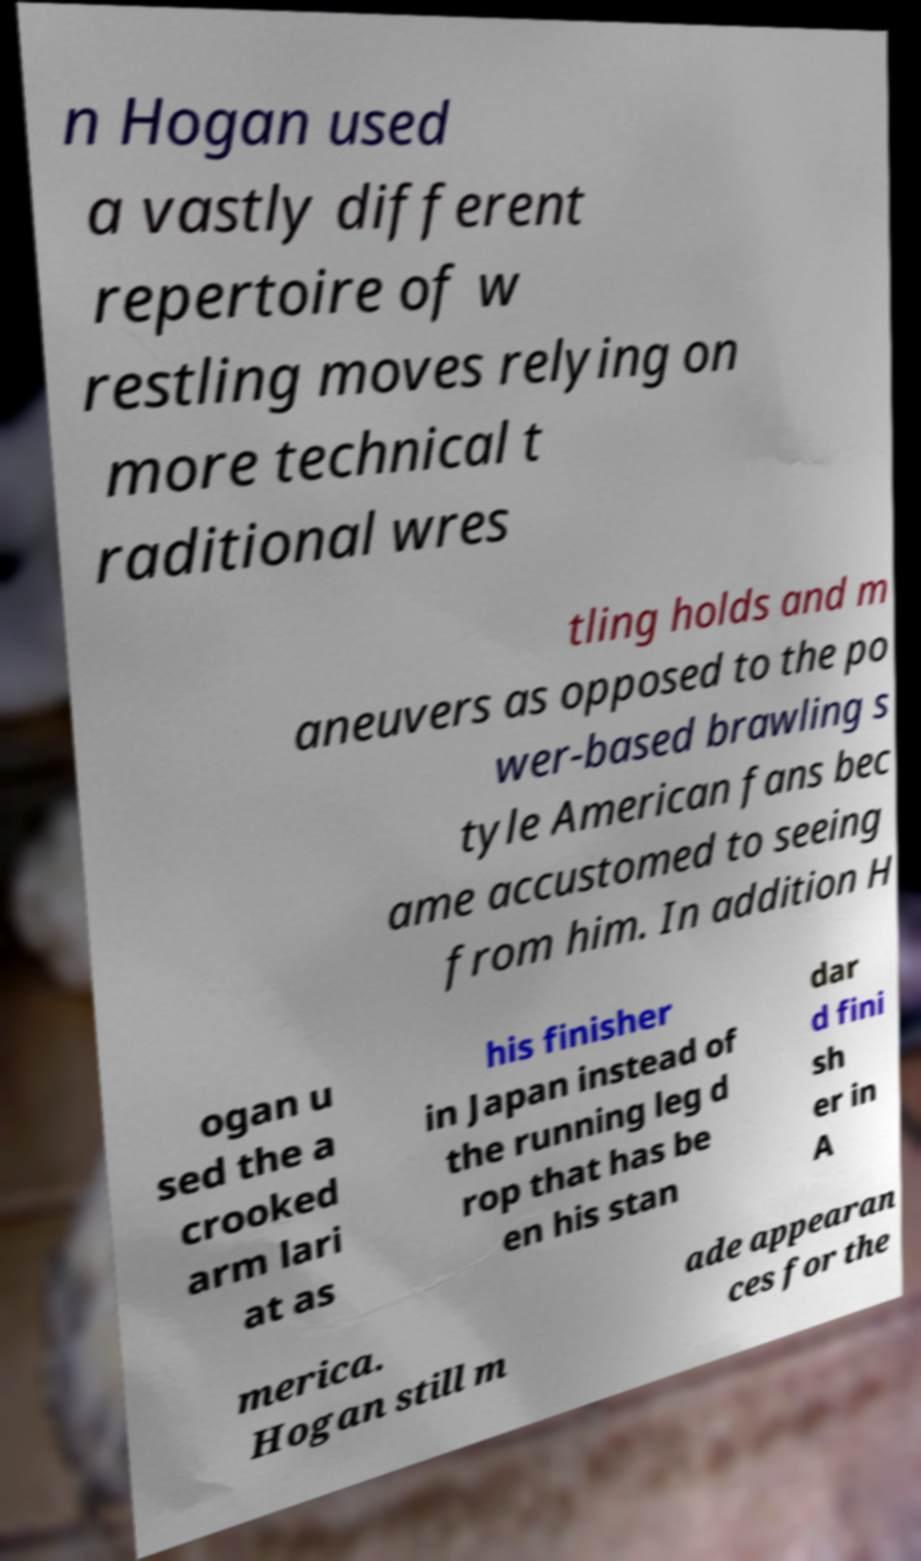Please identify and transcribe the text found in this image. n Hogan used a vastly different repertoire of w restling moves relying on more technical t raditional wres tling holds and m aneuvers as opposed to the po wer-based brawling s tyle American fans bec ame accustomed to seeing from him. In addition H ogan u sed the a crooked arm lari at as his finisher in Japan instead of the running leg d rop that has be en his stan dar d fini sh er in A merica. Hogan still m ade appearan ces for the 